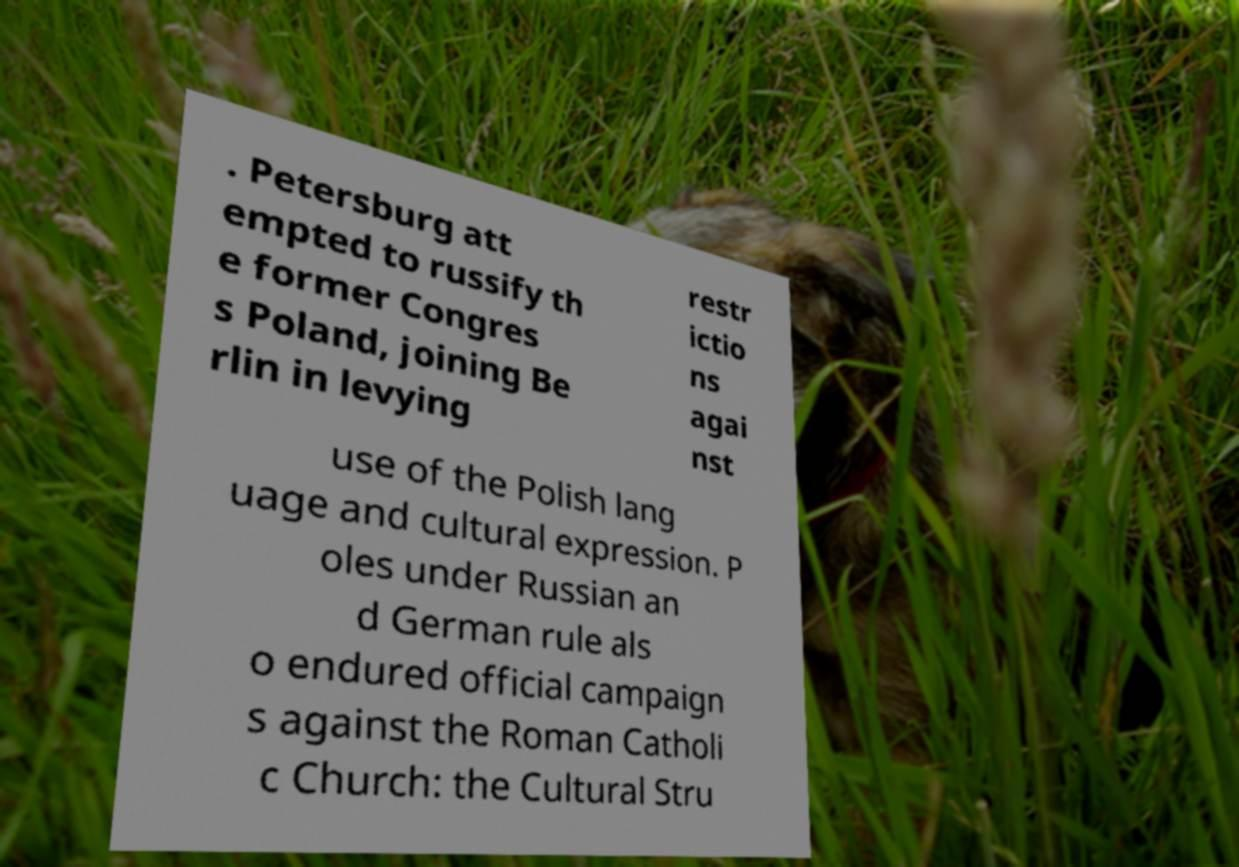Could you extract and type out the text from this image? . Petersburg att empted to russify th e former Congres s Poland, joining Be rlin in levying restr ictio ns agai nst use of the Polish lang uage and cultural expression. P oles under Russian an d German rule als o endured official campaign s against the Roman Catholi c Church: the Cultural Stru 